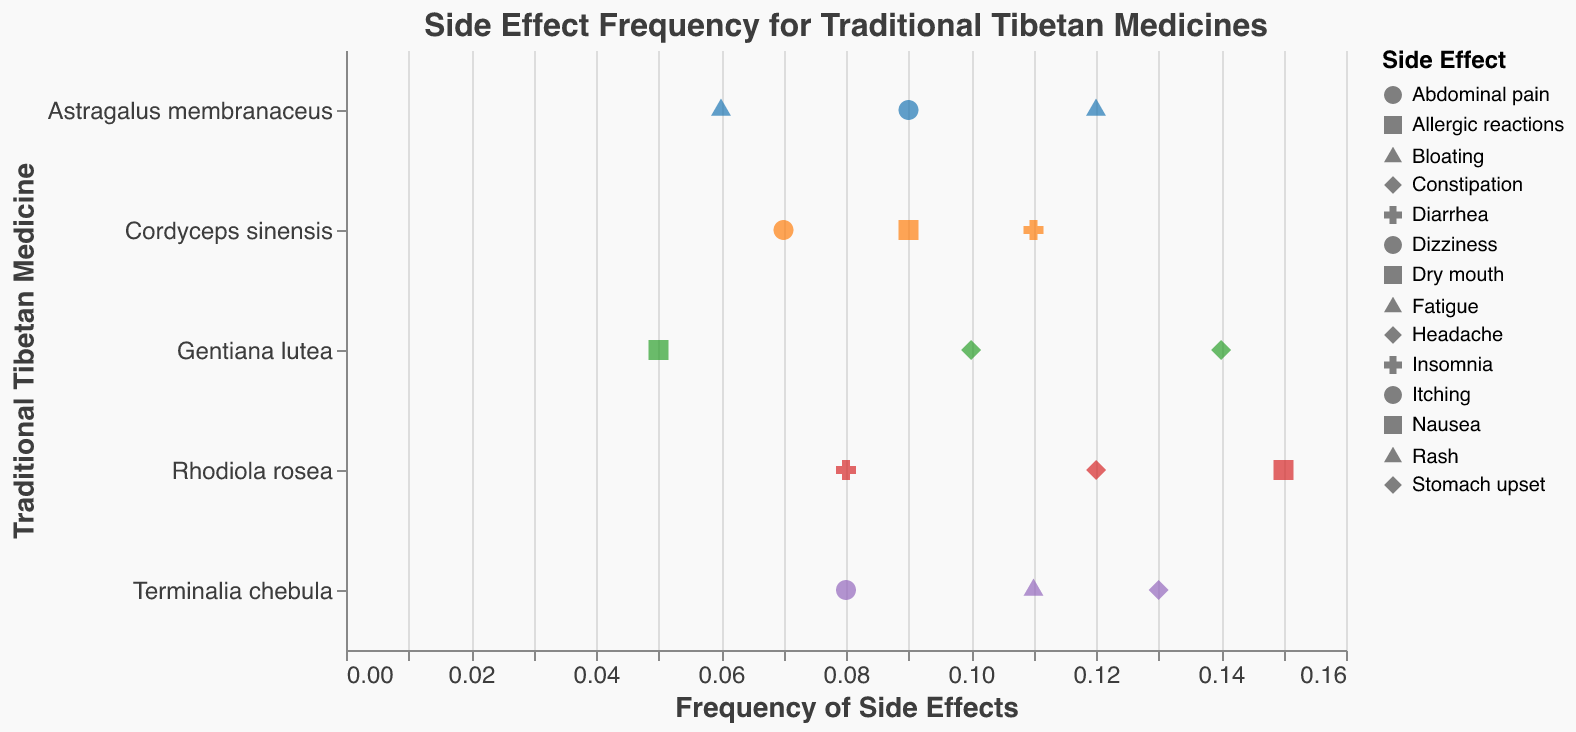What's the title of the figure? The title of the figure appears at the top and reads "Side Effect Frequency for Traditional Tibetan Medicines".
Answer: Side Effect Frequency for Traditional Tibetan Medicines Which side effect has the highest frequency for Rhodiola rosea? Look at the data points corresponding to Rhodiola rosea and compare their frequencies. The highest frequency is 0.15 for Dry mouth.
Answer: Dry mouth Which traditional Tibetan medicine has the side effect with the lowest frequency? Compare the frequencies of all the side effects. The lowest frequency is 0.05 for Allergic reactions in Gentiana lutea.
Answer: Gentiana lutea What is the total number of side effects reported for Cordyceps sinensis? Count all the data points corresponding to Cordyceps sinensis. There are three side effects: Nausea, Diarrhea, and Dizziness.
Answer: 3 Which side effect has the highest overall frequency in the dataset? Check all the data points and find the one with the highest frequency. The highest frequency is 0.15 for Dry mouth in Rhodiola rosea.
Answer: Dry mouth Which medicine has the most data points represented in the strip plot? Count the number of data points for each medicine. Rhodiola rosea, Gentiana lutea, Terminalia chebula, and Astragalus membranaceus each have 3 data points, while Cordyceps sinensis has 3.
Answer: Rhodiola rosea, Gentiana lutea, Terminalia chebula, Astragalus membranaceus, Cordyceps sinensis (tie) What is the average frequency of the side effects reported for Terminalia chebula? Sum the frequencies for Terminalia chebula (0.13, 0.08, 0.11) and divide by the number of side effects (3). (0.13 + 0.08 + 0.11) / 3 = 0.1067
Answer: 0.1067 Which medicine has the most varied side effect frequencies? Compare the range of side effect frequencies for each medicine by subtracting the minimum frequency from the maximum frequency for each medicine. Rhodiola rosea: 0.15 - 0.08 = 0.07 Cordyceps sinensis: 0.11 - 0.07 = 0.04 Gentiana lutea: 0.14 - 0.05 = 0.09 Terminalia chebula: 0.13 - 0.08 = 0.05 Astragalus membranaceus: 0.12 - 0.06 = 0.06 The highest range (0.09) is for Gentiana lutea.
Answer: Gentiana lutea How many medicines report headache as a side effect? Identify data points where the side effect is headache and count the corresponding medicines. Rhodiola rosea and Gentiana lutea report headache.
Answer: 2 Which medicine has the side effect 'Fatigue'? Look for the data point where the side effect is 'Fatigue' and note the associated medicine. The medicine is Astragalus membranaceus.
Answer: Astragalus membranaceus 